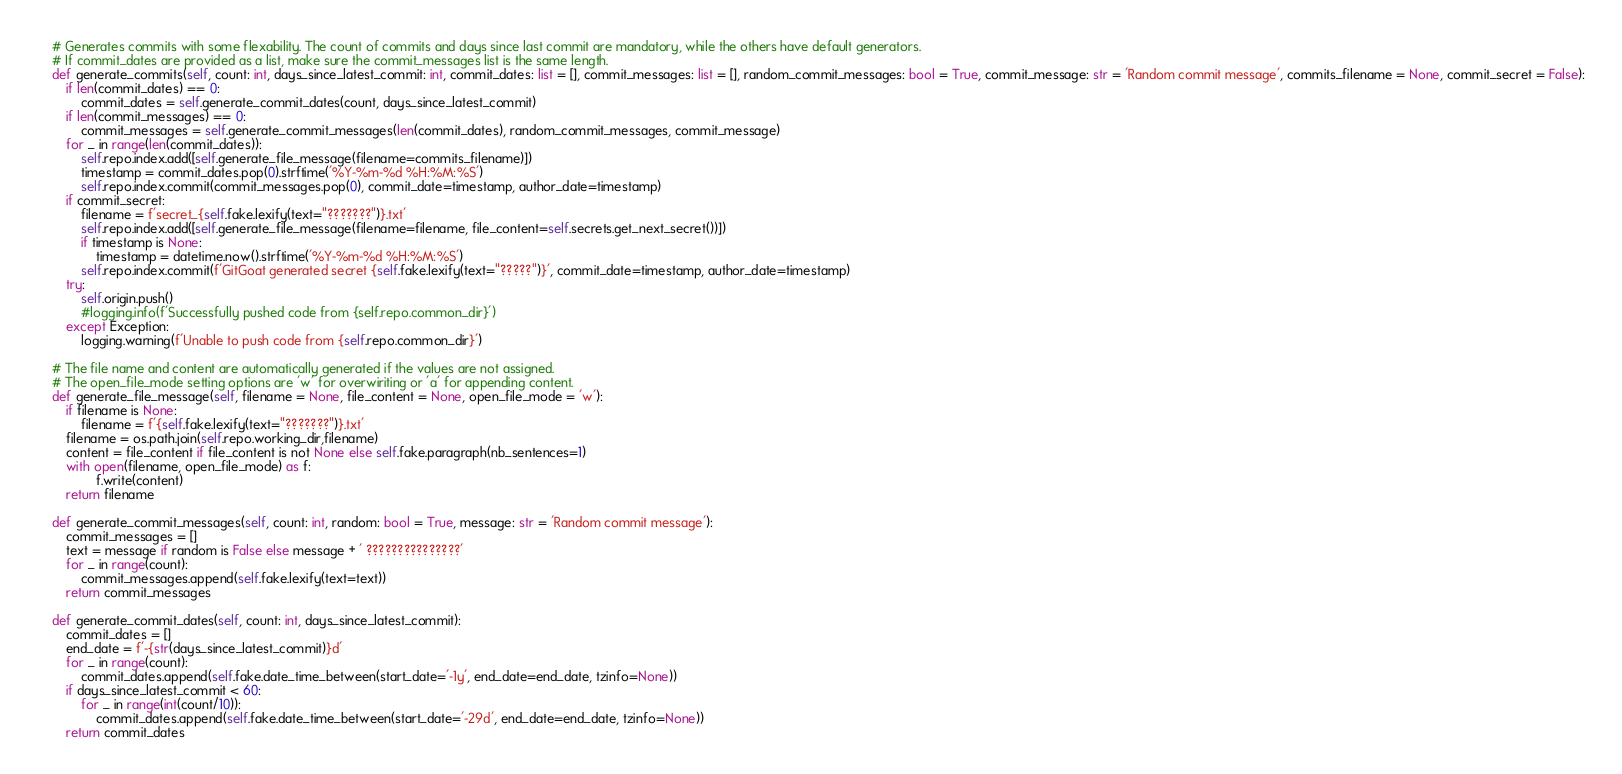Convert code to text. <code><loc_0><loc_0><loc_500><loc_500><_Python_>
    # Generates commits with some flexability. The count of commits and days since last commit are mandatory, while the others have default generators. 
    # If commit_dates are provided as a list, make sure the commit_messages list is the same length. 
    def generate_commits(self, count: int, days_since_latest_commit: int, commit_dates: list = [], commit_messages: list = [], random_commit_messages: bool = True, commit_message: str = 'Random commit message', commits_filename = None, commit_secret = False):
        if len(commit_dates) == 0:
            commit_dates = self.generate_commit_dates(count, days_since_latest_commit)
        if len(commit_messages) == 0:
            commit_messages = self.generate_commit_messages(len(commit_dates), random_commit_messages, commit_message)
        for _ in range(len(commit_dates)):
            self.repo.index.add([self.generate_file_message(filename=commits_filename)])
            timestamp = commit_dates.pop(0).strftime('%Y-%m-%d %H:%M:%S')
            self.repo.index.commit(commit_messages.pop(0), commit_date=timestamp, author_date=timestamp)
        if commit_secret:
            filename = f'secret_{self.fake.lexify(text="???????")}.txt'
            self.repo.index.add([self.generate_file_message(filename=filename, file_content=self.secrets.get_next_secret())])
            if timestamp is None:
                timestamp = datetime.now().strftime('%Y-%m-%d %H:%M:%S')
            self.repo.index.commit(f'GitGoat generated secret {self.fake.lexify(text="?????")}', commit_date=timestamp, author_date=timestamp)
        try:
            self.origin.push()
            #logging.info(f'Successfully pushed code from {self.repo.common_dir}')
        except Exception:
            logging.warning(f'Unable to push code from {self.repo.common_dir}')

    # The file name and content are automatically generated if the values are not assigned.
    # The open_file_mode setting options are 'w' for overwiriting or 'a' for appending content. 
    def generate_file_message(self, filename = None, file_content = None, open_file_mode = 'w'):
        if filename is None:
            filename = f'{self.fake.lexify(text="???????")}.txt'
        filename = os.path.join(self.repo.working_dir,filename)
        content = file_content if file_content is not None else self.fake.paragraph(nb_sentences=1)
        with open(filename, open_file_mode) as f:
                f.write(content)
        return filename

    def generate_commit_messages(self, count: int, random: bool = True, message: str = 'Random commit message'):
        commit_messages = []
        text = message if random is False else message + ' ???????????????' 
        for _ in range(count):
            commit_messages.append(self.fake.lexify(text=text))
        return commit_messages

    def generate_commit_dates(self, count: int, days_since_latest_commit):
        commit_dates = []
        end_date = f'-{str(days_since_latest_commit)}d'
        for _ in range(count):
            commit_dates.append(self.fake.date_time_between(start_date='-1y', end_date=end_date, tzinfo=None))
        if days_since_latest_commit < 60:
            for _ in range(int(count/10)):
                commit_dates.append(self.fake.date_time_between(start_date='-29d', end_date=end_date, tzinfo=None))       
        return commit_dates</code> 